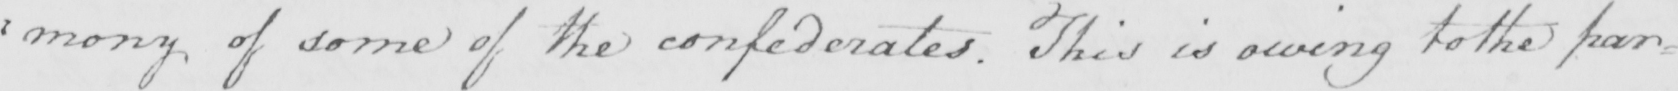Transcribe the text shown in this historical manuscript line. : mony of some of the confederates . This is owing to the par= 